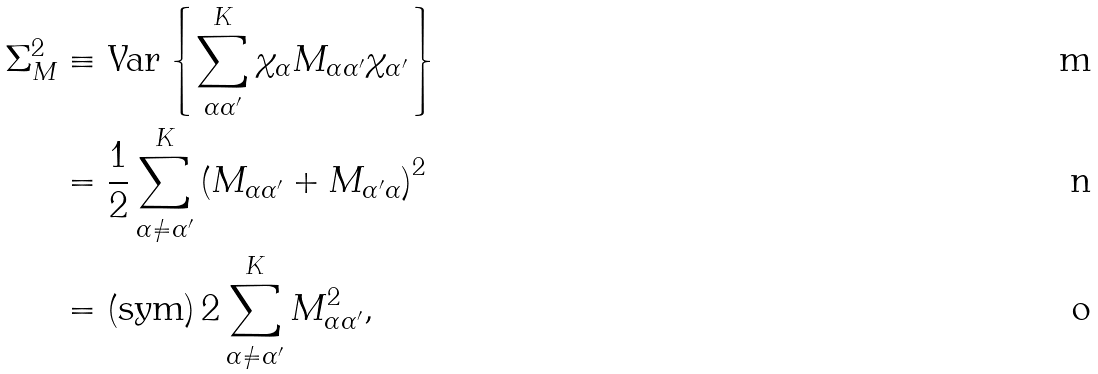Convert formula to latex. <formula><loc_0><loc_0><loc_500><loc_500>\Sigma _ { M } ^ { 2 } & \equiv \text {Var} \left \{ \sum _ { \alpha \alpha ^ { \prime } } ^ { K } \chi _ { \alpha } M _ { \alpha \alpha ^ { \prime } } \chi _ { \alpha ^ { \prime } } \right \} \\ & = \frac { 1 } { 2 } \sum _ { \alpha \ne \alpha ^ { \prime } } ^ { K } \left ( M _ { \alpha \alpha ^ { \prime } } + M _ { \alpha ^ { \prime } \alpha } \right ) ^ { 2 } \\ & = \left ( \text {sym} \right ) 2 \sum _ { \alpha \ne \alpha ^ { \prime } } ^ { K } M _ { \alpha \alpha ^ { \prime } } ^ { 2 } ,</formula> 